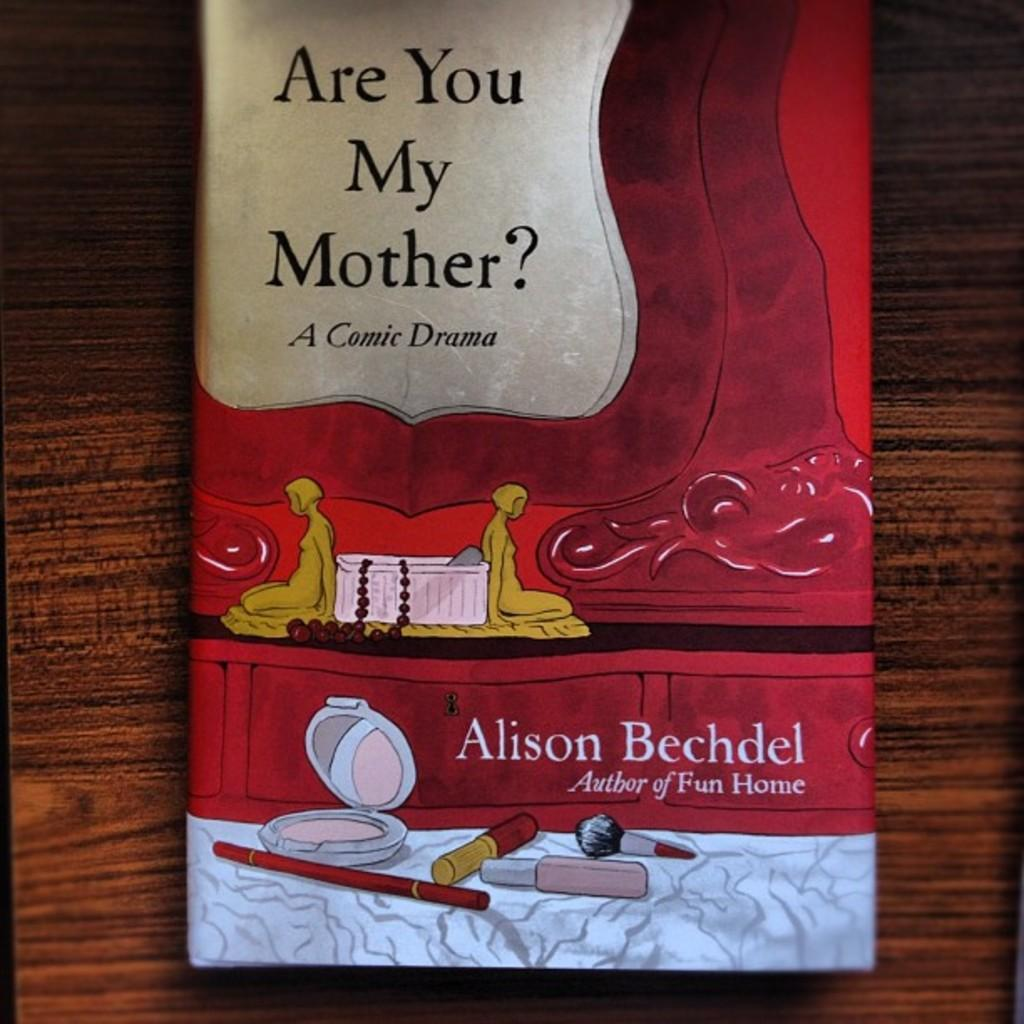<image>
Relay a brief, clear account of the picture shown. A book by Alison Bechdel has drawings of makeup on the cover. 